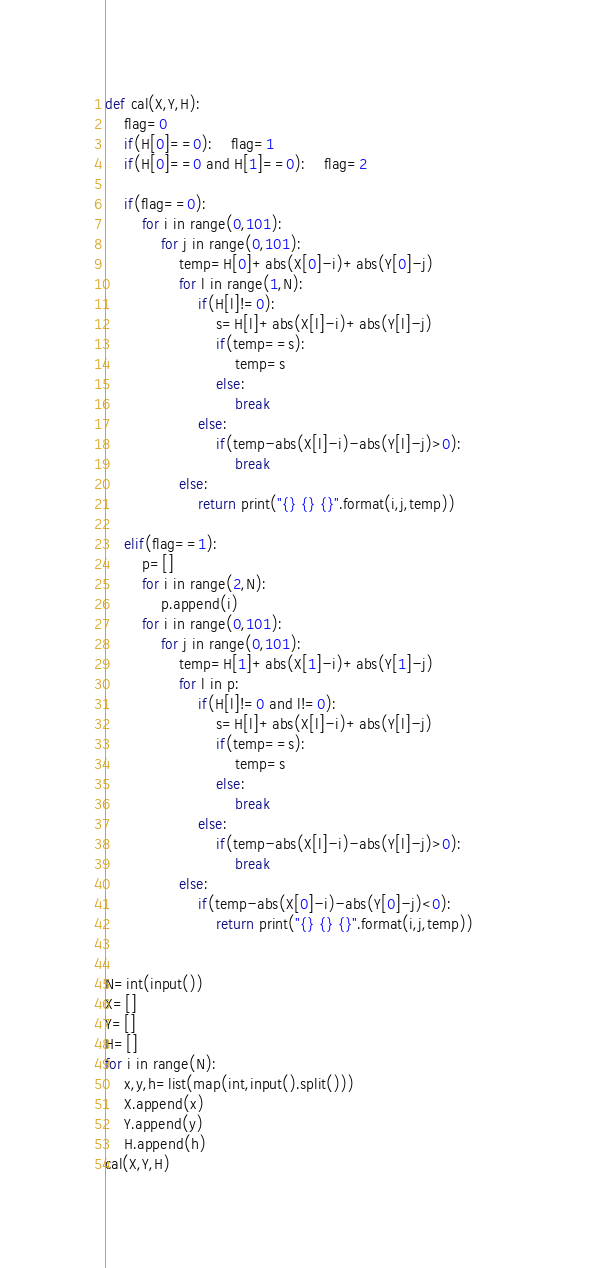Convert code to text. <code><loc_0><loc_0><loc_500><loc_500><_Python_>def cal(X,Y,H):
    flag=0
    if(H[0]==0):    flag=1
    if(H[0]==0 and H[1]==0):    flag=2
    
    if(flag==0):
        for i in range(0,101):
            for j in range(0,101):
                temp=H[0]+abs(X[0]-i)+abs(Y[0]-j)
                for l in range(1,N):
                    if(H[l]!=0):
                        s=H[l]+abs(X[l]-i)+abs(Y[l]-j)
                        if(temp==s):
                            temp=s
                        else:
                            break
                    else:
                        if(temp-abs(X[l]-i)-abs(Y[l]-j)>0):
                            break
                else:
                    return print("{} {} {}".format(i,j,temp))
            
    elif(flag==1):
        p=[]
        for i in range(2,N):
            p.append(i)
        for i in range(0,101):
            for j in range(0,101):
                temp=H[1]+abs(X[1]-i)+abs(Y[1]-j)
                for l in p:
                    if(H[l]!=0 and l!=0):
                        s=H[l]+abs(X[l]-i)+abs(Y[l]-j)
                        if(temp==s):
                            temp=s
                        else:
                            break
                    else:
                        if(temp-abs(X[l]-i)-abs(Y[l]-j)>0):
                            break
                else:
                    if(temp-abs(X[0]-i)-abs(Y[0]-j)<0):
                        return print("{} {} {}".format(i,j,temp))          
    

N=int(input())
X=[]
Y=[]
H=[]
for i in range(N):
    x,y,h=list(map(int,input().split()))
    X.append(x)
    Y.append(y)
    H.append(h)
cal(X,Y,H)</code> 